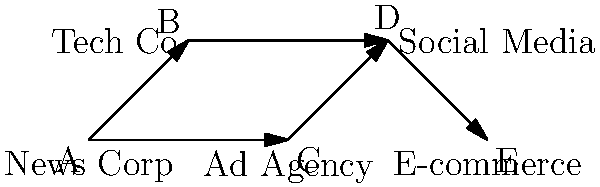In the network diagram above, companies are represented by nodes, and ownership or significant investments are represented by arrows. As a media executive responsible for maintaining journalistic integrity, which relationship in this network poses the highest risk for a potential conflict of interest in reporting corporate scandals? To identify the highest risk for a potential conflict of interest, we need to analyze the relationships in the network:

1. Company A (News Corp) has ownership or significant investments in:
   - Company B (Tech Co)
   - Company C (Ad Agency)

2. Company B (Tech Co) has ownership or significant investments in:
   - Company D (Social Media)

3. Company C (Ad Agency) has ownership or significant investments in:
   - Company D (Social Media)

4. Company D (Social Media) has ownership or significant investments in:
   - Company E (E-commerce)

5. The most concerning relationship for maintaining journalistic integrity is between Company A (News Corp) and Company D (Social Media) because:
   a. News Corp indirectly controls or influences the Social Media company through two separate channels (Tech Co and Ad Agency).
   b. Social Media platforms are increasingly becoming primary sources of news distribution.
   c. This dual-path influence could potentially lead to manipulation of news content or suppression of certain stories on the social media platform.

6. The relationship between News Corp and E-commerce (through Social Media) is less direct and therefore poses a lower risk.

7. The direct relationships between News Corp and Tech Co or Ad Agency are less concerning as they are more transparent and easier to disclose.

Therefore, the relationship between Company A (News Corp) and Company D (Social Media) poses the highest risk for a potential conflict of interest in reporting corporate scandals.
Answer: News Corp (A) - Social Media (D) relationship 